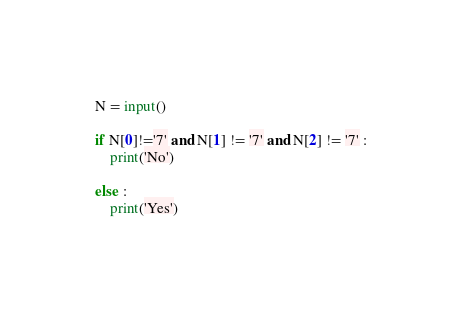<code> <loc_0><loc_0><loc_500><loc_500><_Python_>N = input()

if N[0]!='7' and N[1] != '7' and N[2] != '7' :
    print('No')

else :
    print('Yes')
</code> 